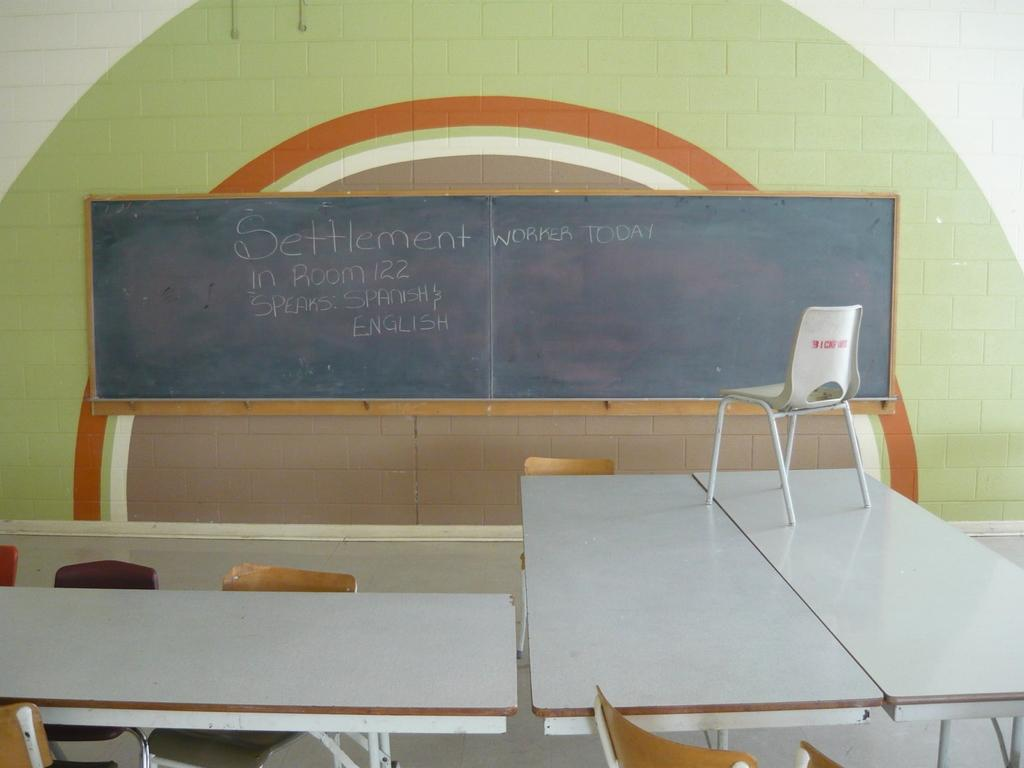<image>
Give a short and clear explanation of the subsequent image. A chalkboard indicates that both English and Spanish are spoken in this classroom. 